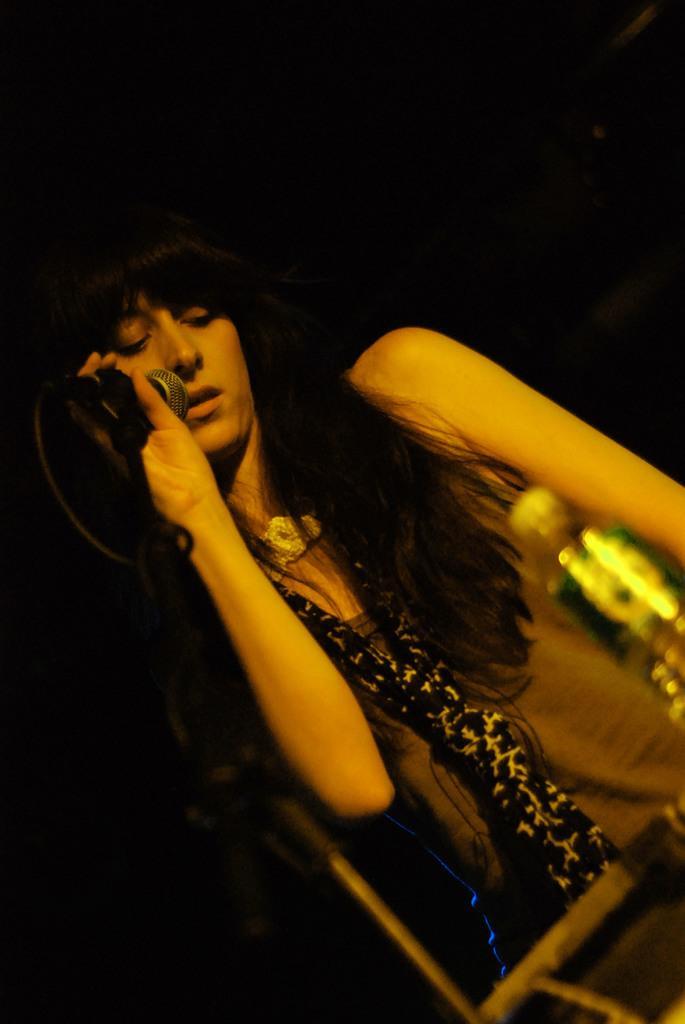In one or two sentences, can you explain what this image depicts? This woman is standing and holds a mic. In-front of this woman there is a bottle. She wore scarf. 